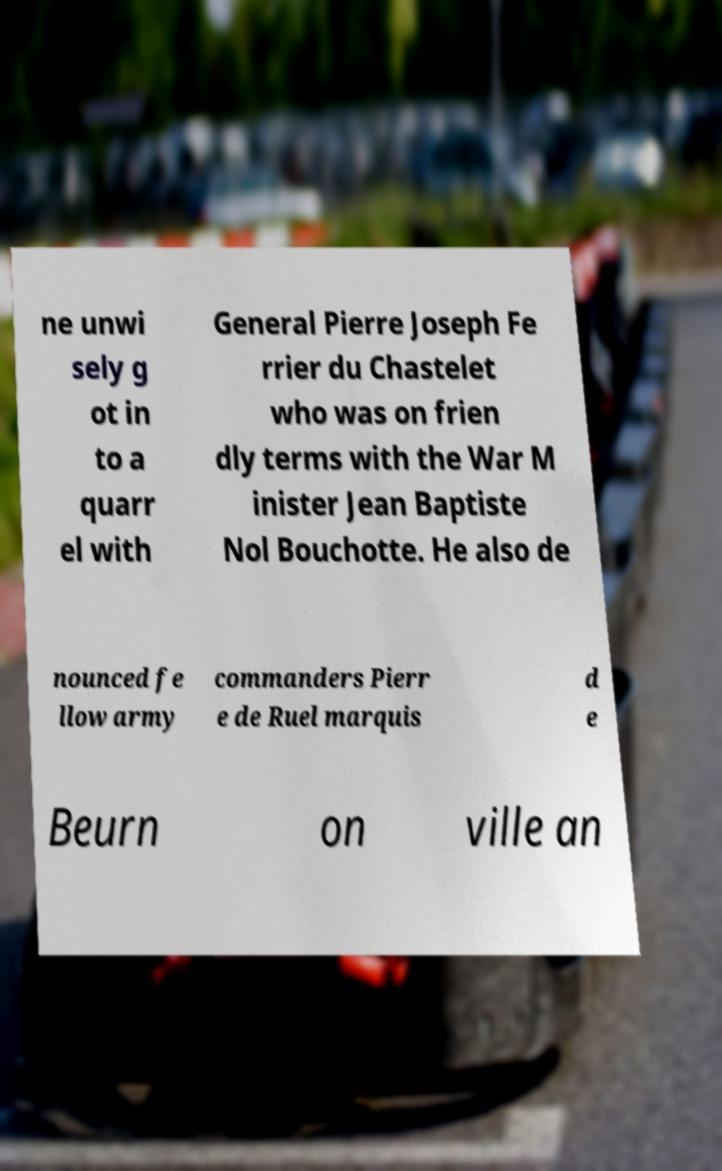Please identify and transcribe the text found in this image. ne unwi sely g ot in to a quarr el with General Pierre Joseph Fe rrier du Chastelet who was on frien dly terms with the War M inister Jean Baptiste Nol Bouchotte. He also de nounced fe llow army commanders Pierr e de Ruel marquis d e Beurn on ville an 